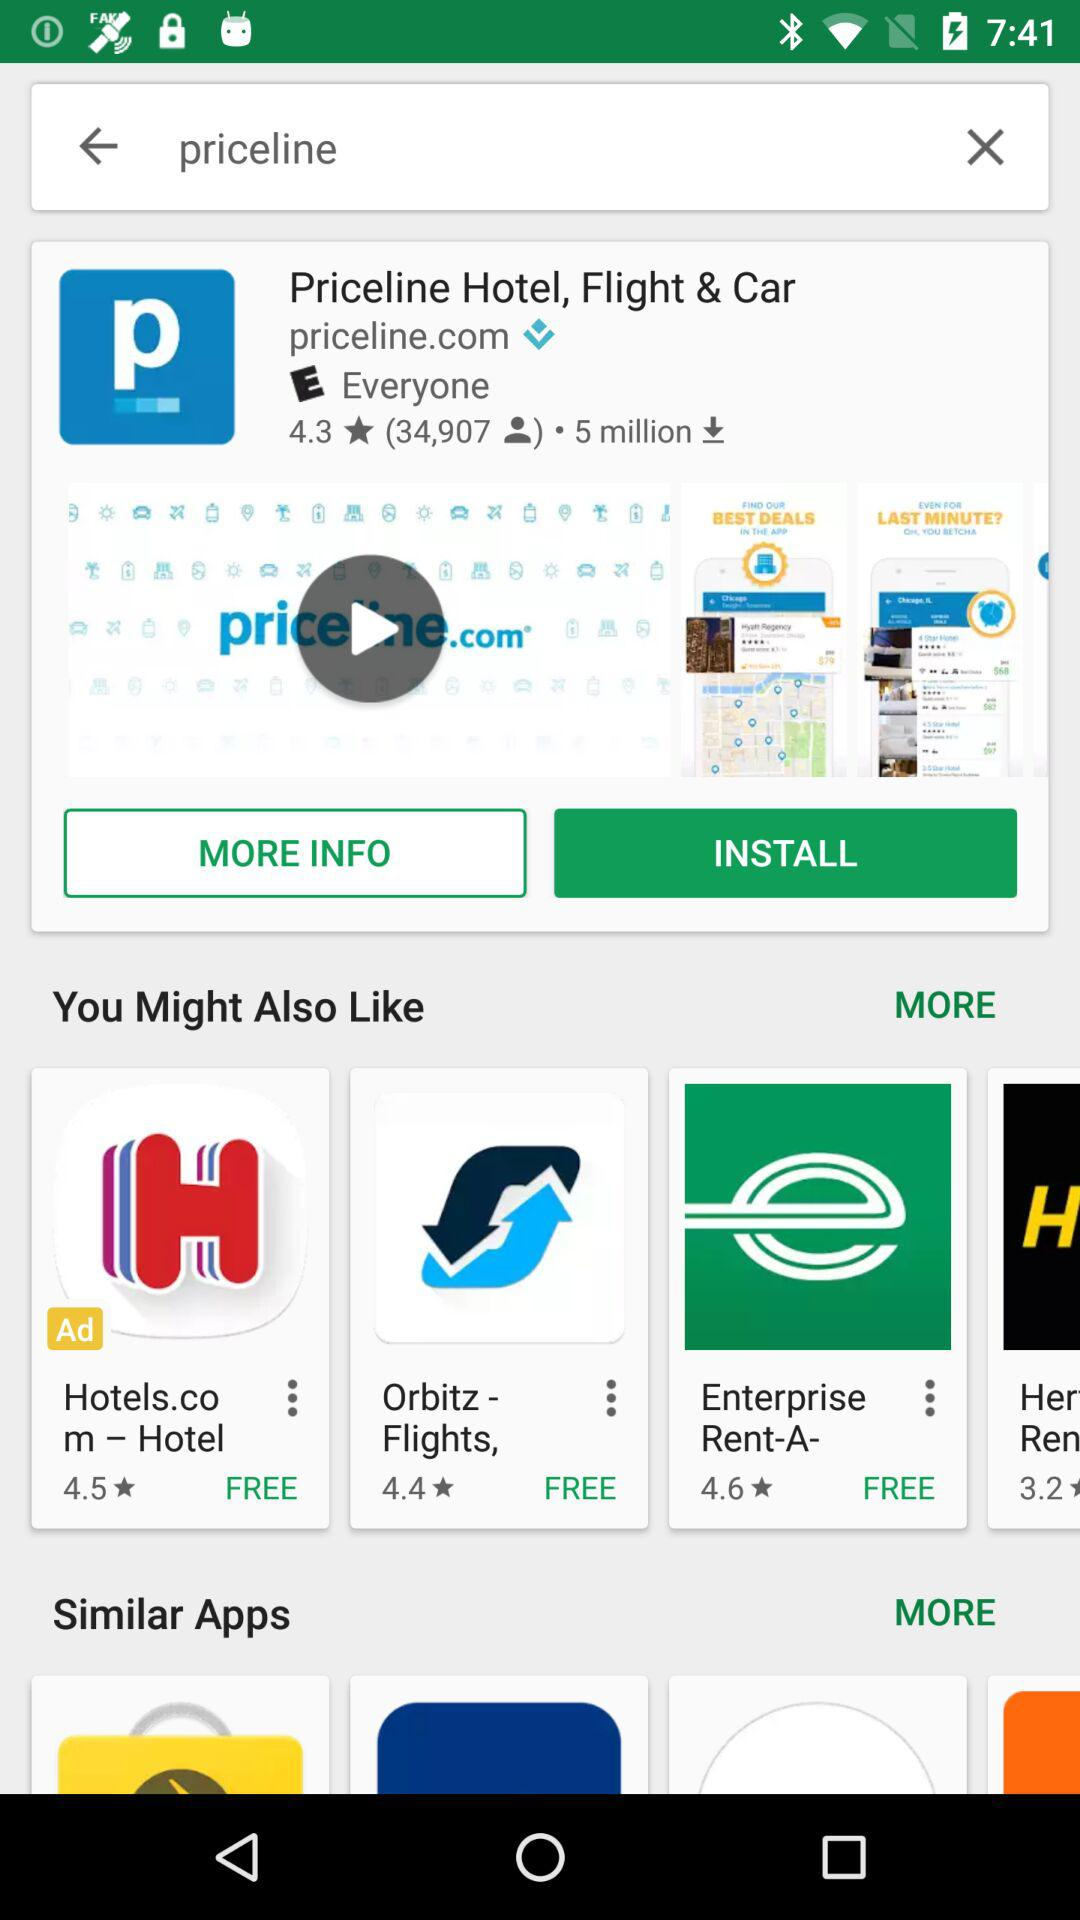Which app has more downloads, Priceline or Her Ren?
Answer the question using a single word or phrase. Priceline 